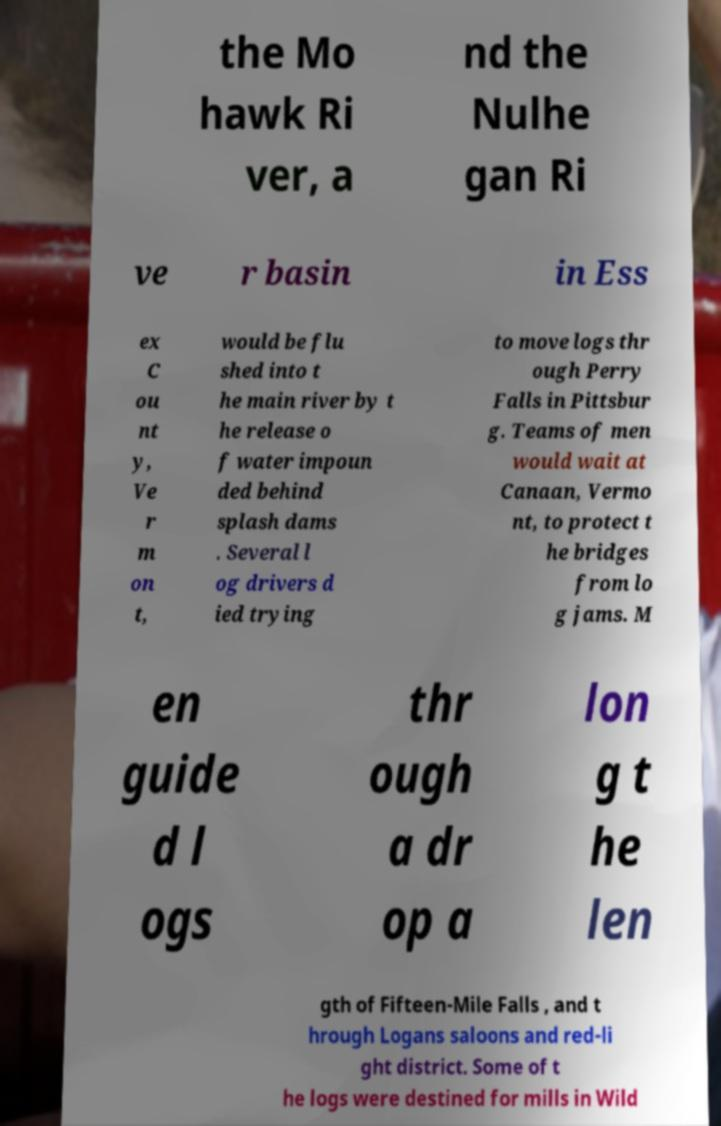I need the written content from this picture converted into text. Can you do that? the Mo hawk Ri ver, a nd the Nulhe gan Ri ve r basin in Ess ex C ou nt y, Ve r m on t, would be flu shed into t he main river by t he release o f water impoun ded behind splash dams . Several l og drivers d ied trying to move logs thr ough Perry Falls in Pittsbur g. Teams of men would wait at Canaan, Vermo nt, to protect t he bridges from lo g jams. M en guide d l ogs thr ough a dr op a lon g t he len gth of Fifteen-Mile Falls , and t hrough Logans saloons and red-li ght district. Some of t he logs were destined for mills in Wild 